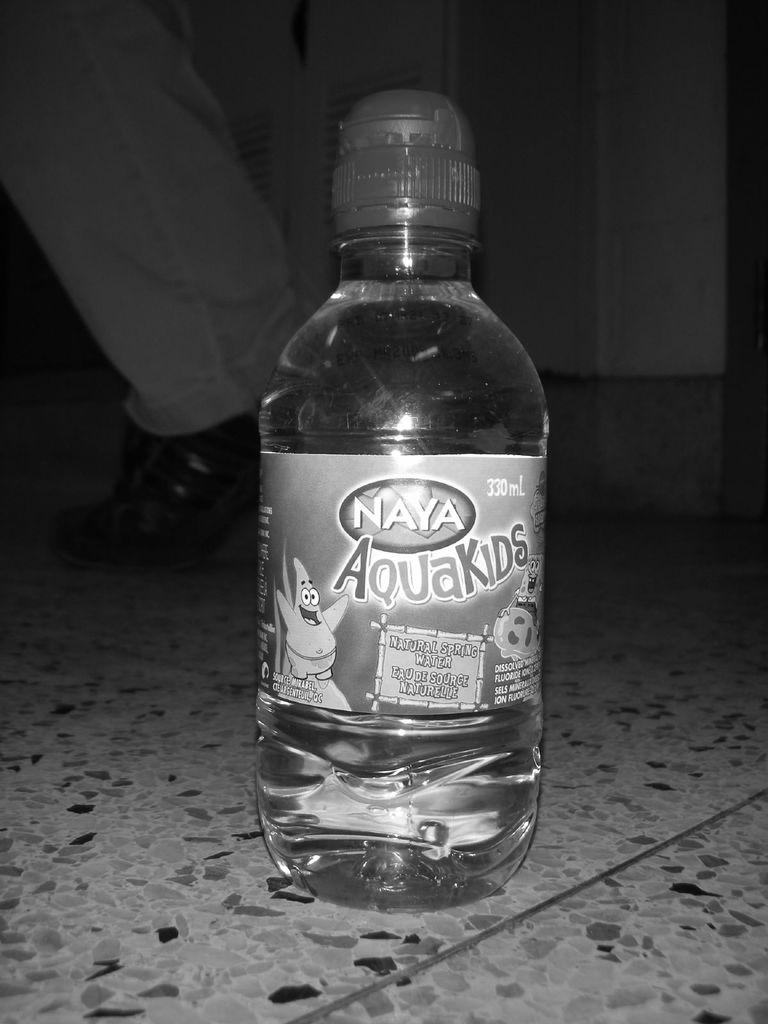What is the color scheme of the image? The image is black and white. What object can be seen on the floor in the image? There is a bottle on the floor in the image. What is written or depicted on the bottle? The bottle has a label on it. Can you describe anything in the background of the image? A leg of a person is visible in the background of the image. What type of bone is the person holding in the image? There is no bone present in the image; only a bottle and a leg of a person are visible. 